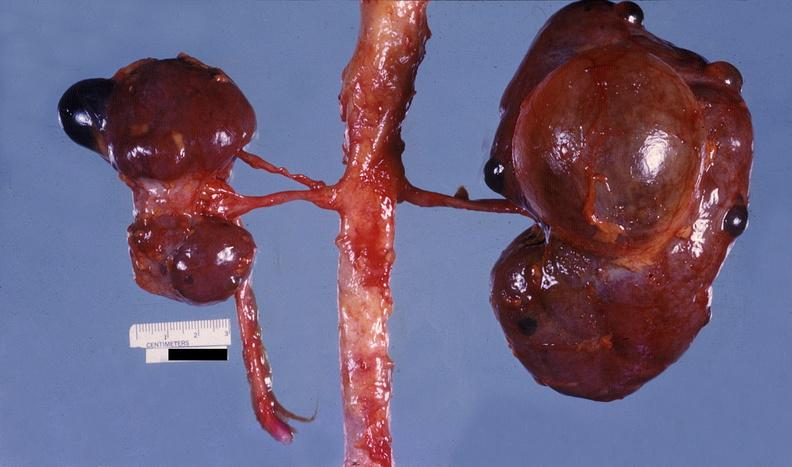does this image show kidney, pyelonephritis?
Answer the question using a single word or phrase. Yes 